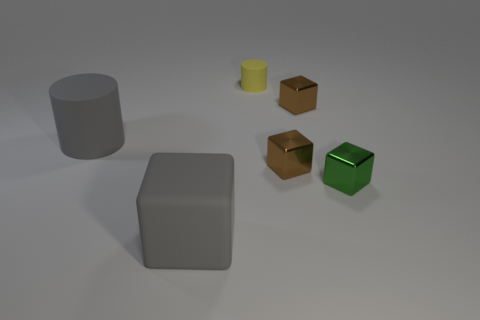Add 3 green blocks. How many objects exist? 9 Subtract all cylinders. How many objects are left? 4 Subtract 0 purple balls. How many objects are left? 6 Subtract all small things. Subtract all large rubber objects. How many objects are left? 0 Add 2 tiny yellow matte objects. How many tiny yellow matte objects are left? 3 Add 4 big cubes. How many big cubes exist? 5 